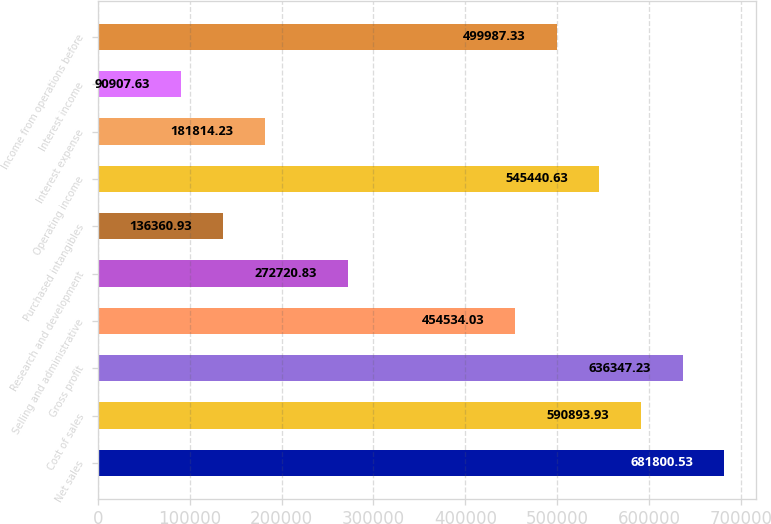Convert chart. <chart><loc_0><loc_0><loc_500><loc_500><bar_chart><fcel>Net sales<fcel>Cost of sales<fcel>Gross profit<fcel>Selling and administrative<fcel>Research and development<fcel>Purchased intangibles<fcel>Operating income<fcel>Interest expense<fcel>Interest income<fcel>Income from operations before<nl><fcel>681801<fcel>590894<fcel>636347<fcel>454534<fcel>272721<fcel>136361<fcel>545441<fcel>181814<fcel>90907.6<fcel>499987<nl></chart> 